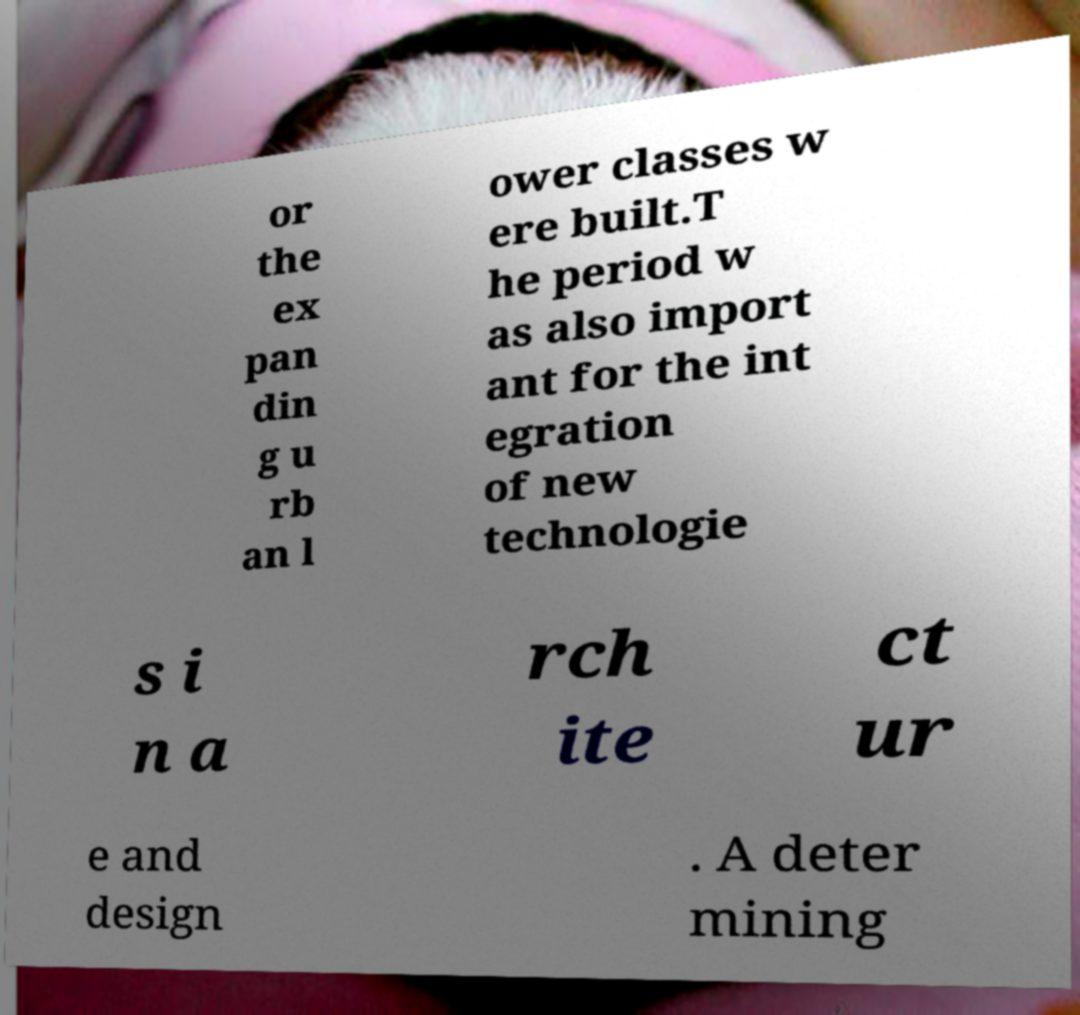Can you accurately transcribe the text from the provided image for me? or the ex pan din g u rb an l ower classes w ere built.T he period w as also import ant for the int egration of new technologie s i n a rch ite ct ur e and design . A deter mining 